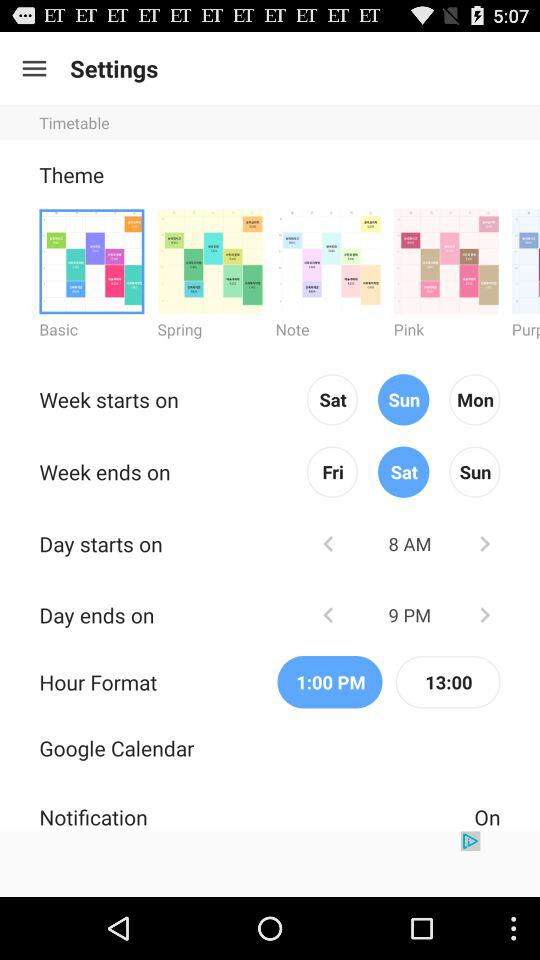How many themes are available to choose from?
Answer the question using a single word or phrase. 5 